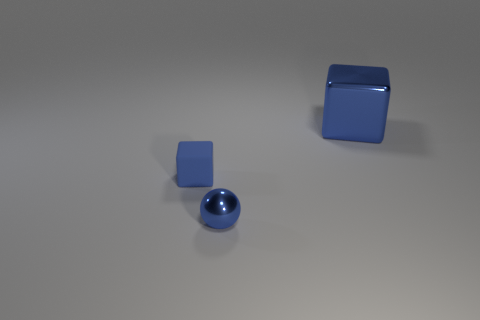Add 3 blue rubber things. How many objects exist? 6 Subtract all cubes. How many objects are left? 1 Add 2 big blue things. How many big blue things are left? 3 Add 1 tiny blue rubber objects. How many tiny blue rubber objects exist? 2 Subtract 0 green cubes. How many objects are left? 3 Subtract all blue balls. Subtract all large blue metal cylinders. How many objects are left? 2 